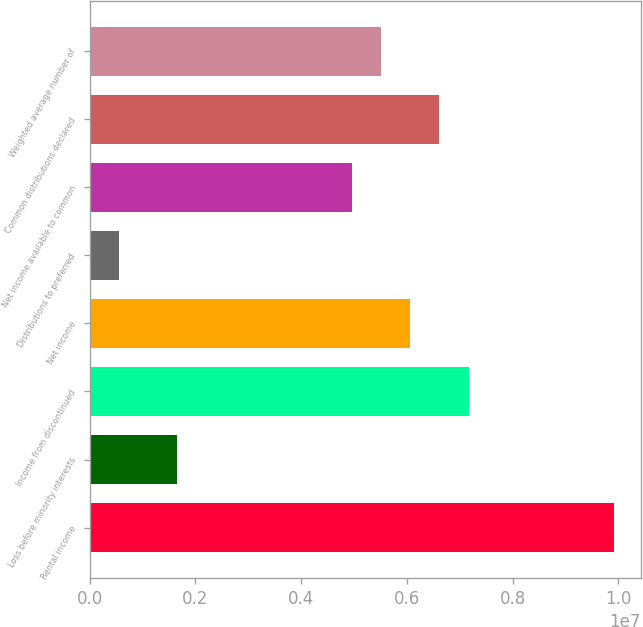<chart> <loc_0><loc_0><loc_500><loc_500><bar_chart><fcel>Rental income<fcel>Loss before minority interests<fcel>Income from discontinued<fcel>Net income<fcel>Distributions to preferred<fcel>Net income available to common<fcel>Common distributions declared<fcel>Weighted average number of<nl><fcel>9.92236e+06<fcel>1.65373e+06<fcel>7.16615e+06<fcel>6.06367e+06<fcel>551243<fcel>4.96118e+06<fcel>6.61491e+06<fcel>5.51242e+06<nl></chart> 